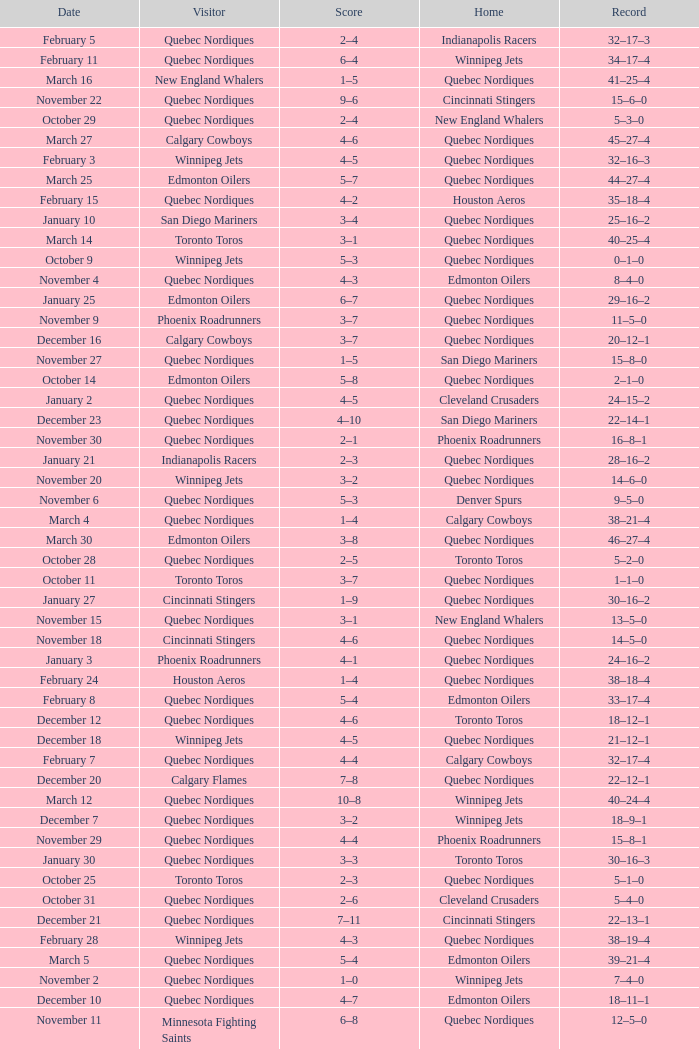What was the date of the game with a score of 2–1? November 30. Could you help me parse every detail presented in this table? {'header': ['Date', 'Visitor', 'Score', 'Home', 'Record'], 'rows': [['February 5', 'Quebec Nordiques', '2–4', 'Indianapolis Racers', '32–17–3'], ['February 11', 'Quebec Nordiques', '6–4', 'Winnipeg Jets', '34–17–4'], ['March 16', 'New England Whalers', '1–5', 'Quebec Nordiques', '41–25–4'], ['November 22', 'Quebec Nordiques', '9–6', 'Cincinnati Stingers', '15–6–0'], ['October 29', 'Quebec Nordiques', '2–4', 'New England Whalers', '5–3–0'], ['March 27', 'Calgary Cowboys', '4–6', 'Quebec Nordiques', '45–27–4'], ['February 3', 'Winnipeg Jets', '4–5', 'Quebec Nordiques', '32–16–3'], ['March 25', 'Edmonton Oilers', '5–7', 'Quebec Nordiques', '44–27–4'], ['February 15', 'Quebec Nordiques', '4–2', 'Houston Aeros', '35–18–4'], ['January 10', 'San Diego Mariners', '3–4', 'Quebec Nordiques', '25–16–2'], ['March 14', 'Toronto Toros', '3–1', 'Quebec Nordiques', '40–25–4'], ['October 9', 'Winnipeg Jets', '5–3', 'Quebec Nordiques', '0–1–0'], ['November 4', 'Quebec Nordiques', '4–3', 'Edmonton Oilers', '8–4–0'], ['January 25', 'Edmonton Oilers', '6–7', 'Quebec Nordiques', '29–16–2'], ['November 9', 'Phoenix Roadrunners', '3–7', 'Quebec Nordiques', '11–5–0'], ['December 16', 'Calgary Cowboys', '3–7', 'Quebec Nordiques', '20–12–1'], ['November 27', 'Quebec Nordiques', '1–5', 'San Diego Mariners', '15–8–0'], ['October 14', 'Edmonton Oilers', '5–8', 'Quebec Nordiques', '2–1–0'], ['January 2', 'Quebec Nordiques', '4–5', 'Cleveland Crusaders', '24–15–2'], ['December 23', 'Quebec Nordiques', '4–10', 'San Diego Mariners', '22–14–1'], ['November 30', 'Quebec Nordiques', '2–1', 'Phoenix Roadrunners', '16–8–1'], ['January 21', 'Indianapolis Racers', '2–3', 'Quebec Nordiques', '28–16–2'], ['November 20', 'Winnipeg Jets', '3–2', 'Quebec Nordiques', '14–6–0'], ['November 6', 'Quebec Nordiques', '5–3', 'Denver Spurs', '9–5–0'], ['March 4', 'Quebec Nordiques', '1–4', 'Calgary Cowboys', '38–21–4'], ['March 30', 'Edmonton Oilers', '3–8', 'Quebec Nordiques', '46–27–4'], ['October 28', 'Quebec Nordiques', '2–5', 'Toronto Toros', '5–2–0'], ['October 11', 'Toronto Toros', '3–7', 'Quebec Nordiques', '1–1–0'], ['January 27', 'Cincinnati Stingers', '1–9', 'Quebec Nordiques', '30–16–2'], ['November 15', 'Quebec Nordiques', '3–1', 'New England Whalers', '13–5–0'], ['November 18', 'Cincinnati Stingers', '4–6', 'Quebec Nordiques', '14–5–0'], ['January 3', 'Phoenix Roadrunners', '4–1', 'Quebec Nordiques', '24–16–2'], ['February 24', 'Houston Aeros', '1–4', 'Quebec Nordiques', '38–18–4'], ['February 8', 'Quebec Nordiques', '5–4', 'Edmonton Oilers', '33–17–4'], ['December 12', 'Quebec Nordiques', '4–6', 'Toronto Toros', '18–12–1'], ['December 18', 'Winnipeg Jets', '4–5', 'Quebec Nordiques', '21–12–1'], ['February 7', 'Quebec Nordiques', '4–4', 'Calgary Cowboys', '32–17–4'], ['December 20', 'Calgary Flames', '7–8', 'Quebec Nordiques', '22–12–1'], ['March 12', 'Quebec Nordiques', '10–8', 'Winnipeg Jets', '40–24–4'], ['December 7', 'Quebec Nordiques', '3–2', 'Winnipeg Jets', '18–9–1'], ['November 29', 'Quebec Nordiques', '4–4', 'Phoenix Roadrunners', '15–8–1'], ['January 30', 'Quebec Nordiques', '3–3', 'Toronto Toros', '30–16–3'], ['October 25', 'Toronto Toros', '2–3', 'Quebec Nordiques', '5–1–0'], ['October 31', 'Quebec Nordiques', '2–6', 'Cleveland Crusaders', '5–4–0'], ['December 21', 'Quebec Nordiques', '7–11', 'Cincinnati Stingers', '22–13–1'], ['February 28', 'Winnipeg Jets', '4–3', 'Quebec Nordiques', '38–19–4'], ['March 5', 'Quebec Nordiques', '5–4', 'Edmonton Oilers', '39–21–4'], ['November 2', 'Quebec Nordiques', '1–0', 'Winnipeg Jets', '7–4–0'], ['December 10', 'Quebec Nordiques', '4–7', 'Edmonton Oilers', '18–11–1'], ['November 11', 'Minnesota Fighting Saints', '6–8', 'Quebec Nordiques', '12–5–0'], ['April 1', 'Edmonton Oilers', '2–7', 'Quebec Nordiques', '47–27–4'], ['January 15', 'Calgary Cowboys', '3–5', 'Quebec Nordiques', '26–16–2'], ['February 12', 'Quebec Nordiques', '4–6', 'Minnesota Fighting Saints', '34–18–4'], ['December 28', 'Quebec Nordiques', '6–1', 'Toronto Toros', '24–14–1'], ['March 7', 'Quebec Nordiques', '2–4', 'Edmonton Oilers', '39–22–4'], ['April 4', 'Quebec Nordiques', '5–4', 'Toronto Toros', '49–27–4'], ['March 21', 'Quebec Nordiques', '6–3', 'Edmonton Oilers', '43–26–4'], ['December 27', 'Edmonton Oilers', '3–6', 'Quebec Nordiques', '23–14–1'], ['October 21', 'New England Whalers', '1–6', 'Quebec Nordiques', '4–1–0'], ['April 3', 'Toronto Toros', '1–5', 'Quebec Nordiques', '48–27–4'], ['January 17', 'Toronto Toros', '3–4', 'Quebec Nordiques', '27–16–2'], ['November 8', 'Indianapolis Racers', '2–3', 'Quebec Nordiques', '10–5–0'], ['December 30', 'Quebec Nordiques', '4–4', 'Minnesota Fighting Saints', '24–14–2'], ['January 31', 'Toronto Toros', '4–8', 'Quebec Nordiques', '31–16–3'], ['April 6', 'Toronto Toros', '6–10', 'Quebec Nordiques', '50–27–4'], ['March 10', 'Quebec Nordiques', '3–10', 'Winnipeg Jets', '39–24–4'], ['March 19', 'Quebec Nordiques', '4–3', 'Toronto Toros', '42–25–4'], ['March 9', 'Quebec Nordiques', '4–7', 'Calgary Cowboys', '39–23–4'], ['November 1', 'Quebec Nordiques', '5–4', 'Indianapolis Racers', '6–4–0'], ['December 5', 'Quebec Nordiques', '4–7', 'Toronto Toros', '17–9–1'], ['February 17', 'San Diego Mariners', '2–5', 'Quebec Nordiques', '36–18–4'], ['November 5', 'Quebec Nordiques', '2–4', 'Calgary Cowboys', '8–5–0'], ['March 20', 'Calgary Cowboys', '8–7', 'Quebec Nordiques', '42–26–4'], ['March 2', 'Quebec Nordiques', '2–5', 'Toronto Toros', '38–20–4'], ['December 13', 'Toronto Toros', '3–6', 'Quebec Nordiques', '19–12–1'], ['December 2', 'Cleveland Crusaders', '2–9', 'Quebec Nordiques', '17–8–1'], ['March 23', 'Cleveland Crusaders', '3–1', 'Quebec Nordiques', '43–27–4'], ['December 9', 'Quebec Nordiques', '1–4', 'Calgary Cowboys', '18–10–1'], ['October 18', 'Houston Aeros', '2–3', 'Quebec Nordiques', '3–1–0'], ['February 22', 'New England Whalers', '0–4', 'Quebec Nordiques', '37–18–4'], ['November 23', 'Quebec Nordiques', '0–4', 'Houston Aeros', '15–7–0']]} 